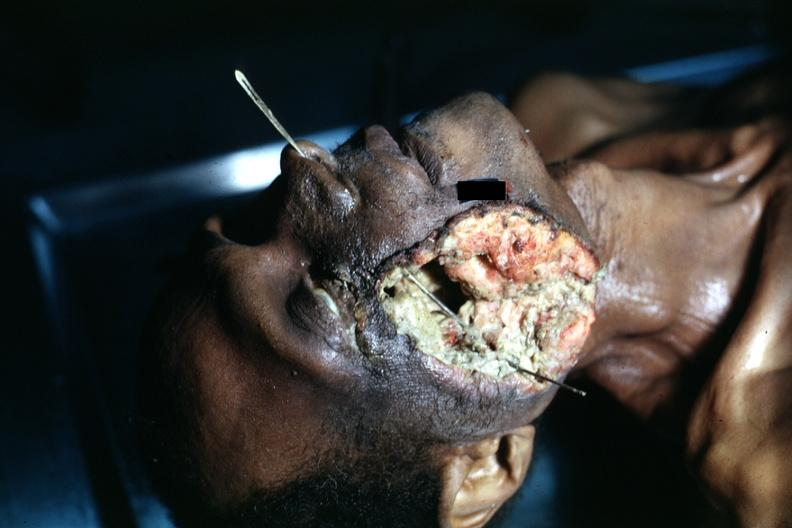what grew to outside?
Answer the question using a single word or phrase. Tumor 